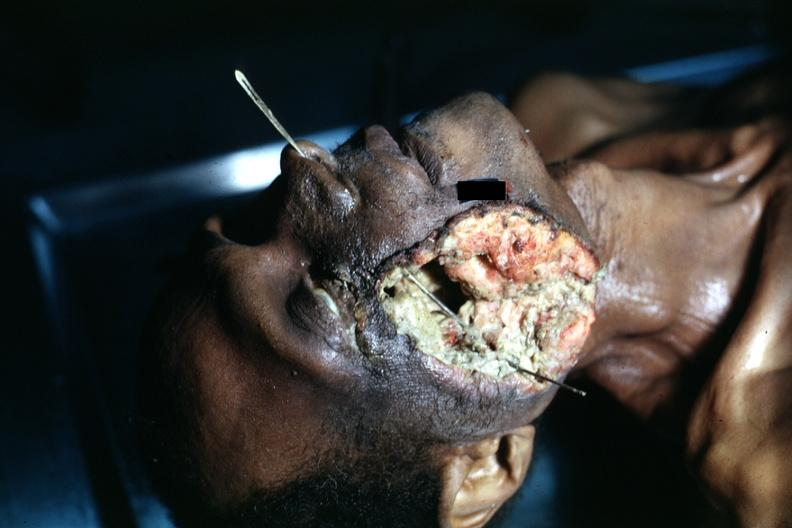what grew to outside?
Answer the question using a single word or phrase. Tumor 